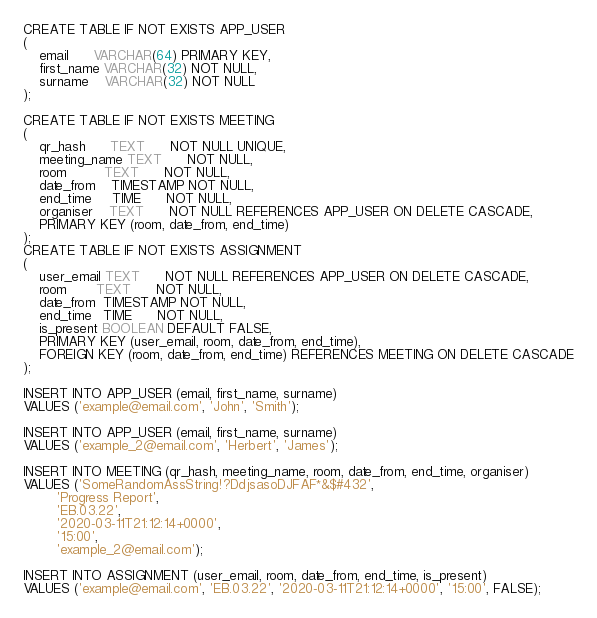<code> <loc_0><loc_0><loc_500><loc_500><_SQL_>CREATE TABLE IF NOT EXISTS APP_USER
(
    email      VARCHAR(64) PRIMARY KEY,
    first_name VARCHAR(32) NOT NULL,
    surname    VARCHAR(32) NOT NULL
);

CREATE TABLE IF NOT EXISTS MEETING
(
    qr_hash      TEXT      NOT NULL UNIQUE,
    meeting_name TEXT      NOT NULL,
    room         TEXT      NOT NULL,
    date_from    TIMESTAMP NOT NULL,
    end_time     TIME      NOT NULL,
    organiser    TEXT      NOT NULL REFERENCES APP_USER ON DELETE CASCADE,
    PRIMARY KEY (room, date_from, end_time)
);
CREATE TABLE IF NOT EXISTS ASSIGNMENT
(
    user_email TEXT      NOT NULL REFERENCES APP_USER ON DELETE CASCADE,
    room       TEXT      NOT NULL,
    date_from  TIMESTAMP NOT NULL,
    end_time   TIME      NOT NULL,
    is_present BOOLEAN DEFAULT FALSE,
    PRIMARY KEY (user_email, room, date_from, end_time),
    FOREIGN KEY (room, date_from, end_time) REFERENCES MEETING ON DELETE CASCADE
);

INSERT INTO APP_USER (email, first_name, surname)
VALUES ('example@email.com', 'John', 'Smith');

INSERT INTO APP_USER (email, first_name, surname)
VALUES ('example_2@email.com', 'Herbert', 'James');

INSERT INTO MEETING (qr_hash, meeting_name, room, date_from, end_time, organiser)
VALUES ('SomeRandomAssString!?DdjsasoDJFAF*&$#432',
        'Progress Report',
        'EB.03.22',
        '2020-03-11T21:12:14+0000',
        '15:00',
        'example_2@email.com');

INSERT INTO ASSIGNMENT (user_email, room, date_from, end_time, is_present)
VALUES ('example@email.com', 'EB.03.22', '2020-03-11T21:12:14+0000', '15:00', FALSE);
</code> 